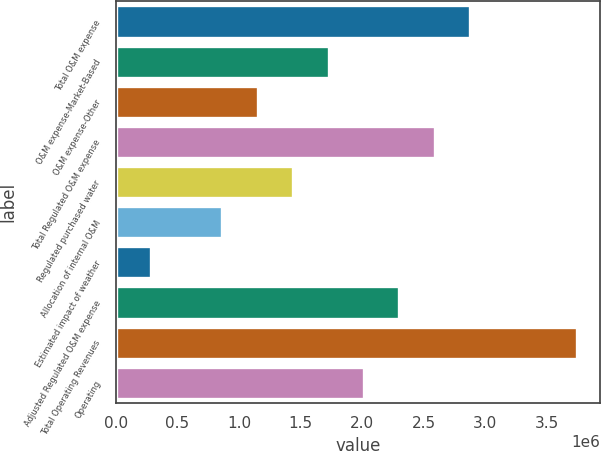<chart> <loc_0><loc_0><loc_500><loc_500><bar_chart><fcel>Total O&M expense<fcel>O&M expense-Market-Based<fcel>O&M expense-Other<fcel>Total Regulated O&M expense<fcel>Regulated purchased water<fcel>Allocation of internal O&M<fcel>Estimated impact of weather<fcel>Adjusted Regulated O&M expense<fcel>Total Operating Revenues<fcel>Operating<nl><fcel>2.87894e+06<fcel>1.72738e+06<fcel>1.1516e+06<fcel>2.59105e+06<fcel>1.43949e+06<fcel>863708<fcel>287928<fcel>2.30316e+06<fcel>3.74261e+06<fcel>2.01527e+06<nl></chart> 